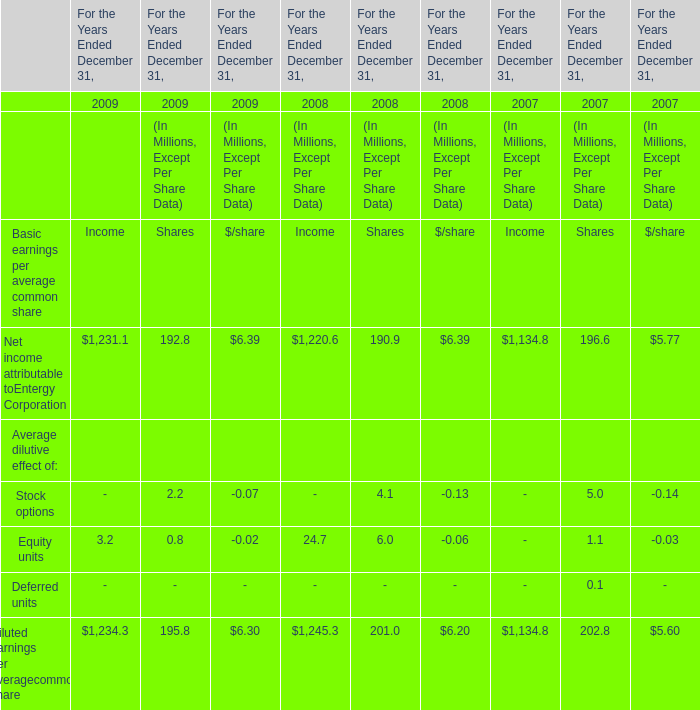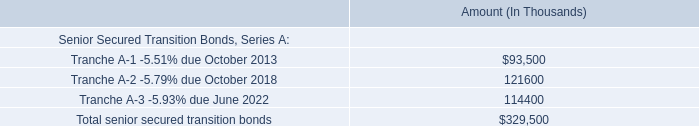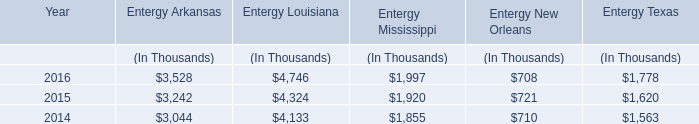How many Diluted earnings per averagecommon share exceed the average of Net income attributable toEntergy Corporation in 2009? 
Answer: 2. 